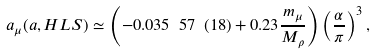<formula> <loc_0><loc_0><loc_500><loc_500>a _ { \mu } ( a , H L S ) \simeq \left ( - 0 . 0 3 5 \ 5 7 \ ( 1 8 ) + 0 . 2 3 { \frac { m _ { \mu } } { M _ { \rho } } } \right ) \left ( { \frac { \alpha } { \pi } } \right ) ^ { 3 } ,</formula> 